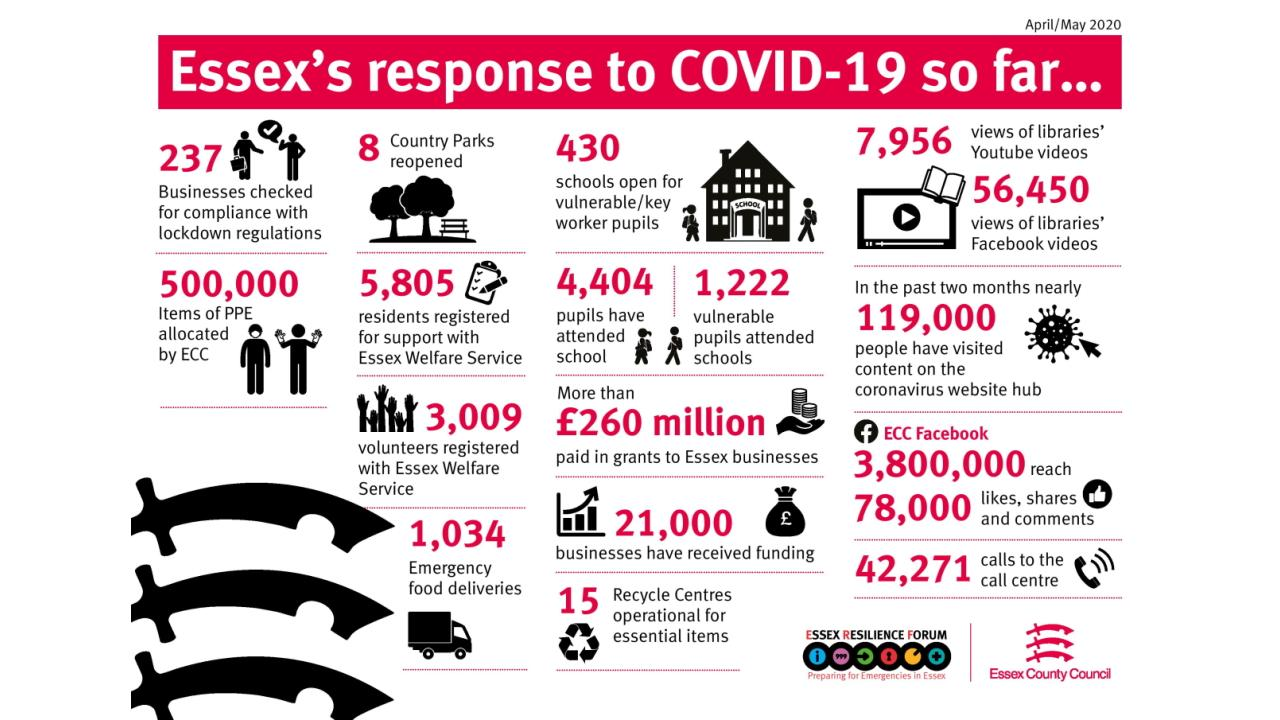Highlight a few significant elements in this photo. A total of 1,222 special children attended classes offline. The Economic Development Administration (EDA) provided assistance to approximately 21,000 firms, which demonstrates the program's effectiveness in supporting businesses in communities across the country. During the pandemic, a total of 1,034 packets of snacks were delivered. A total of 5,805 people sought assistance from Essex. Eight recreational gardens were restarted. 